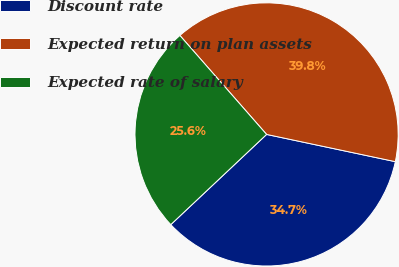Convert chart. <chart><loc_0><loc_0><loc_500><loc_500><pie_chart><fcel>Discount rate<fcel>Expected return on plan assets<fcel>Expected rate of salary<nl><fcel>34.66%<fcel>39.77%<fcel>25.57%<nl></chart> 